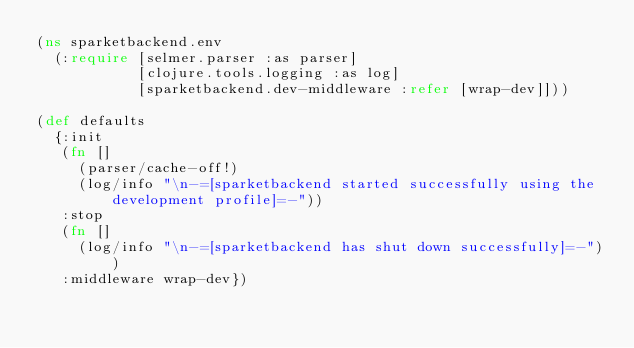Convert code to text. <code><loc_0><loc_0><loc_500><loc_500><_Clojure_>(ns sparketbackend.env
  (:require [selmer.parser :as parser]
            [clojure.tools.logging :as log]
            [sparketbackend.dev-middleware :refer [wrap-dev]]))

(def defaults
  {:init
   (fn []
     (parser/cache-off!)
     (log/info "\n-=[sparketbackend started successfully using the development profile]=-"))
   :stop
   (fn []
     (log/info "\n-=[sparketbackend has shut down successfully]=-"))
   :middleware wrap-dev})
</code> 